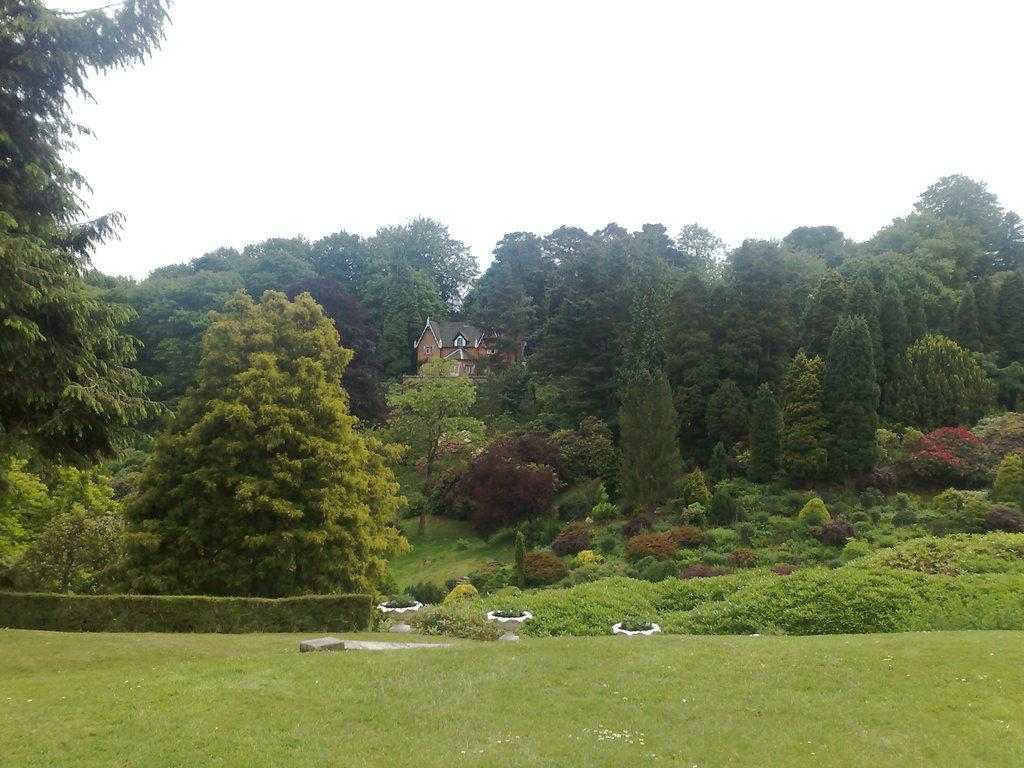What type of vegetation is at the bottom of the image? There is grass at the bottom of the image. What can be seen in the background of the image? There are trees, plants, and a house in the background of the image. What is visible at the top of the image? The sky is visible at the top of the image. What type of nerve can be seen in the image? There is no nerve present in the image; it features grass, trees, plants, a house, and the sky. Can you tell me how many ornaments are hanging from the trees in the image? There are no ornaments present in the image; it only features trees, plants, a house, and the sky. 